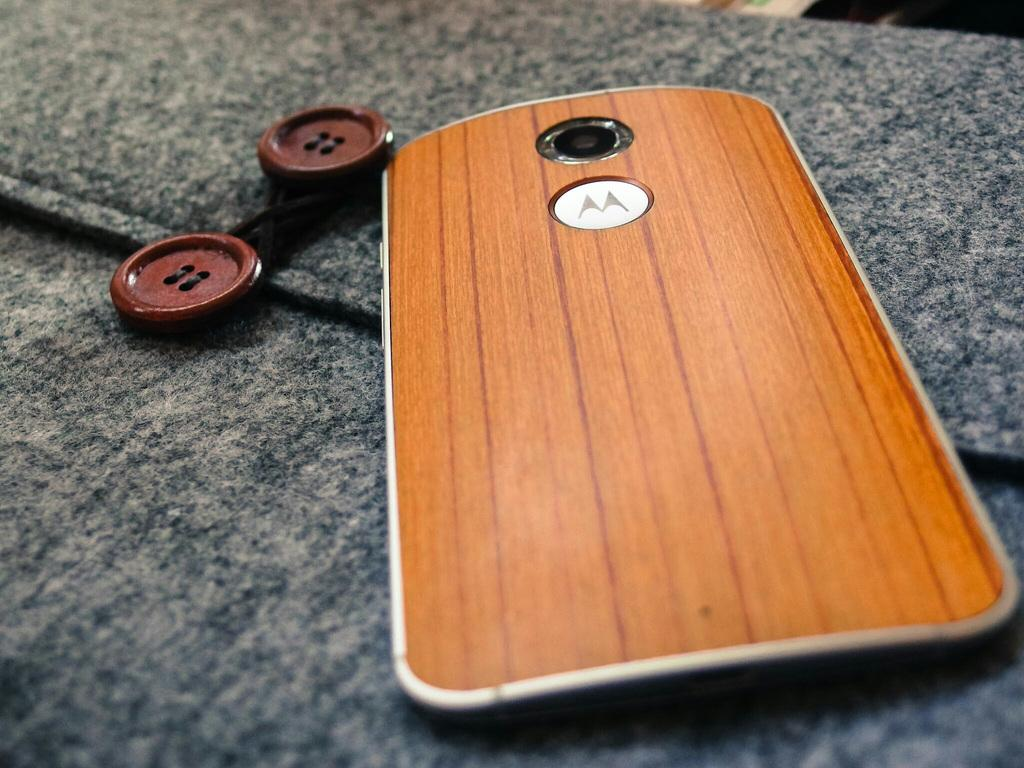<image>
Create a compact narrative representing the image presented. motorola phone with woodgrain back laying on a wood coar 